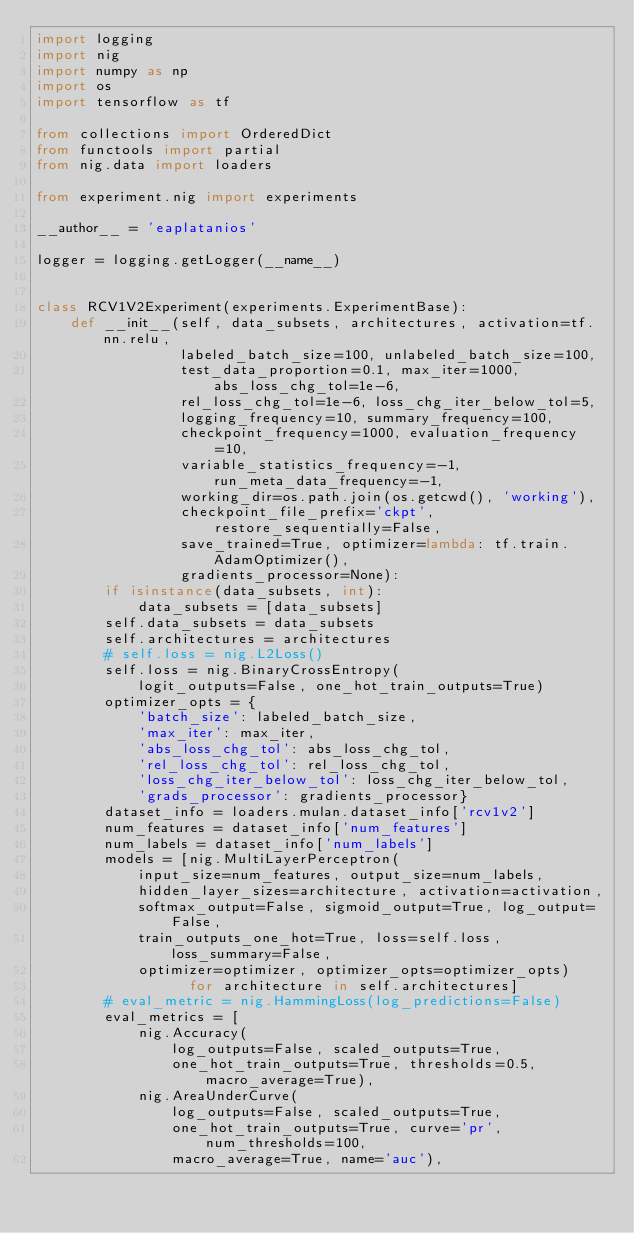<code> <loc_0><loc_0><loc_500><loc_500><_Python_>import logging
import nig
import numpy as np
import os
import tensorflow as tf

from collections import OrderedDict
from functools import partial
from nig.data import loaders

from experiment.nig import experiments

__author__ = 'eaplatanios'

logger = logging.getLogger(__name__)


class RCV1V2Experiment(experiments.ExperimentBase):
    def __init__(self, data_subsets, architectures, activation=tf.nn.relu,
                 labeled_batch_size=100, unlabeled_batch_size=100,
                 test_data_proportion=0.1, max_iter=1000, abs_loss_chg_tol=1e-6,
                 rel_loss_chg_tol=1e-6, loss_chg_iter_below_tol=5,
                 logging_frequency=10, summary_frequency=100,
                 checkpoint_frequency=1000, evaluation_frequency=10,
                 variable_statistics_frequency=-1, run_meta_data_frequency=-1,
                 working_dir=os.path.join(os.getcwd(), 'working'),
                 checkpoint_file_prefix='ckpt', restore_sequentially=False,
                 save_trained=True, optimizer=lambda: tf.train.AdamOptimizer(),
                 gradients_processor=None):
        if isinstance(data_subsets, int):
            data_subsets = [data_subsets]
        self.data_subsets = data_subsets
        self.architectures = architectures
        # self.loss = nig.L2Loss()
        self.loss = nig.BinaryCrossEntropy(
            logit_outputs=False, one_hot_train_outputs=True)
        optimizer_opts = {
            'batch_size': labeled_batch_size,
            'max_iter': max_iter,
            'abs_loss_chg_tol': abs_loss_chg_tol,
            'rel_loss_chg_tol': rel_loss_chg_tol,
            'loss_chg_iter_below_tol': loss_chg_iter_below_tol,
            'grads_processor': gradients_processor}
        dataset_info = loaders.mulan.dataset_info['rcv1v2']
        num_features = dataset_info['num_features']
        num_labels = dataset_info['num_labels']
        models = [nig.MultiLayerPerceptron(
            input_size=num_features, output_size=num_labels,
            hidden_layer_sizes=architecture, activation=activation,
            softmax_output=False, sigmoid_output=True, log_output=False,
            train_outputs_one_hot=True, loss=self.loss, loss_summary=False,
            optimizer=optimizer, optimizer_opts=optimizer_opts)
                  for architecture in self.architectures]
        # eval_metric = nig.HammingLoss(log_predictions=False)
        eval_metrics = [
            nig.Accuracy(
                log_outputs=False, scaled_outputs=True,
                one_hot_train_outputs=True, thresholds=0.5, macro_average=True),
            nig.AreaUnderCurve(
                log_outputs=False, scaled_outputs=True,
                one_hot_train_outputs=True, curve='pr', num_thresholds=100,
                macro_average=True, name='auc'),</code> 